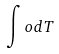<formula> <loc_0><loc_0><loc_500><loc_500>\int o d T</formula> 